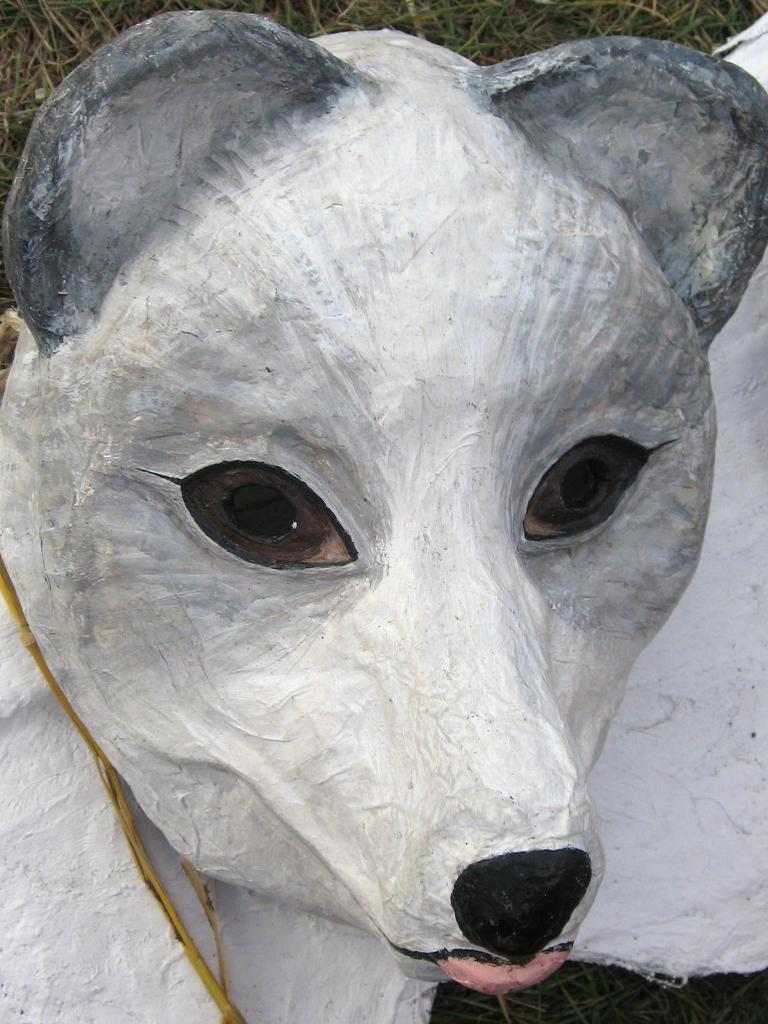What is the main subject of the image? There is a statue of an animal in the image. What type of vegetation can be seen in the image? There is grass visible in the image. What type of plantation can be seen in the background of the image? There is no plantation present in the image; it only features a statue of an animal and grass. What type of vacation is the animal taking in the image? The image does not depict a vacation or any activity involving the animal; it is a statue. 